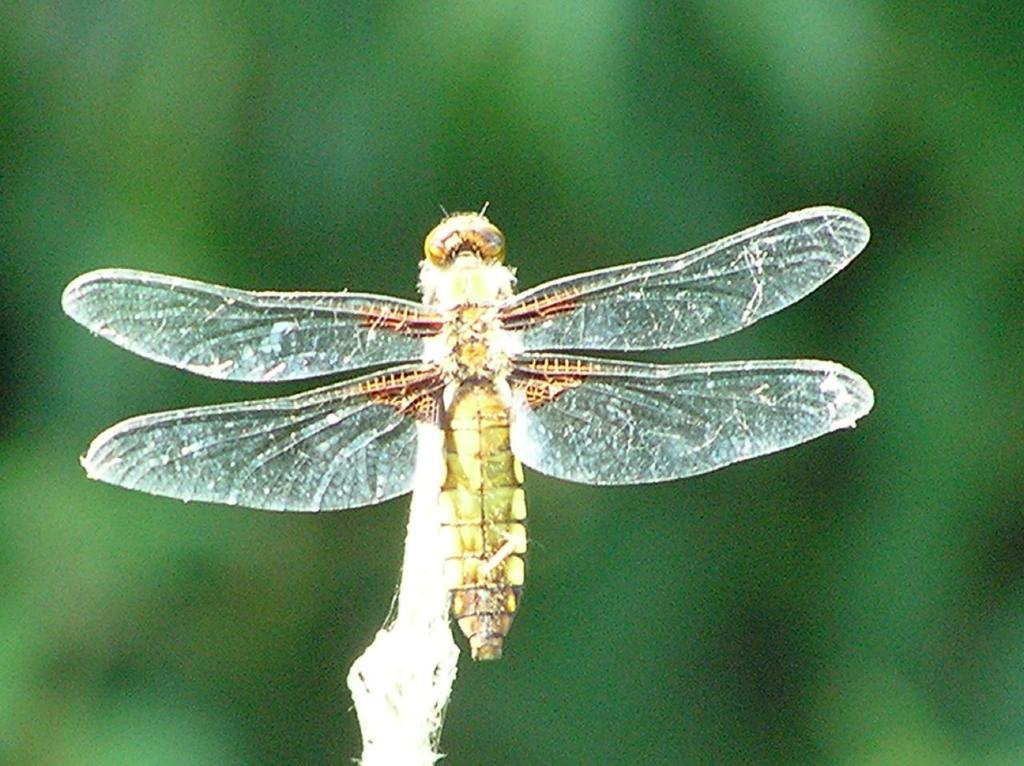What type of creature can be seen in the image? There is an insect in the picture. Can you describe the background of the image? The background of the image is blurry. How many beds are visible in the image? There are no beds present in the image. What type of farm animals can be seen in the image? There are no farm animals present in the image. 